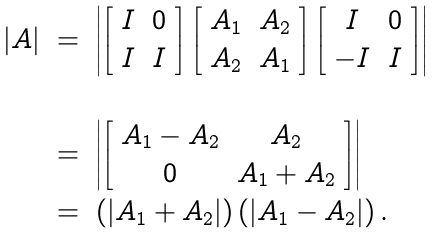Convert formula to latex. <formula><loc_0><loc_0><loc_500><loc_500>\begin{array} { r c l } | A | & = & \left | \left [ \begin{array} { c c } I & 0 \\ I & I \end{array} \right ] \left [ \begin{array} { c c } A _ { 1 } & A _ { 2 } \\ A _ { 2 } & A _ { 1 } \end{array} \right ] \left [ \begin{array} { c c } I & 0 \\ - I & I \end{array} \right ] \right | \\ \\ & = & \left | \left [ \begin{array} { c c } A _ { 1 } - A _ { 2 } & A _ { 2 } \\ 0 & A _ { 1 } + A _ { 2 } \end{array} \right ] \right | \\ & = & \left ( | A _ { 1 } + A _ { 2 } | \right ) \left ( | A _ { 1 } - A _ { 2 } | \right ) . \end{array}</formula> 